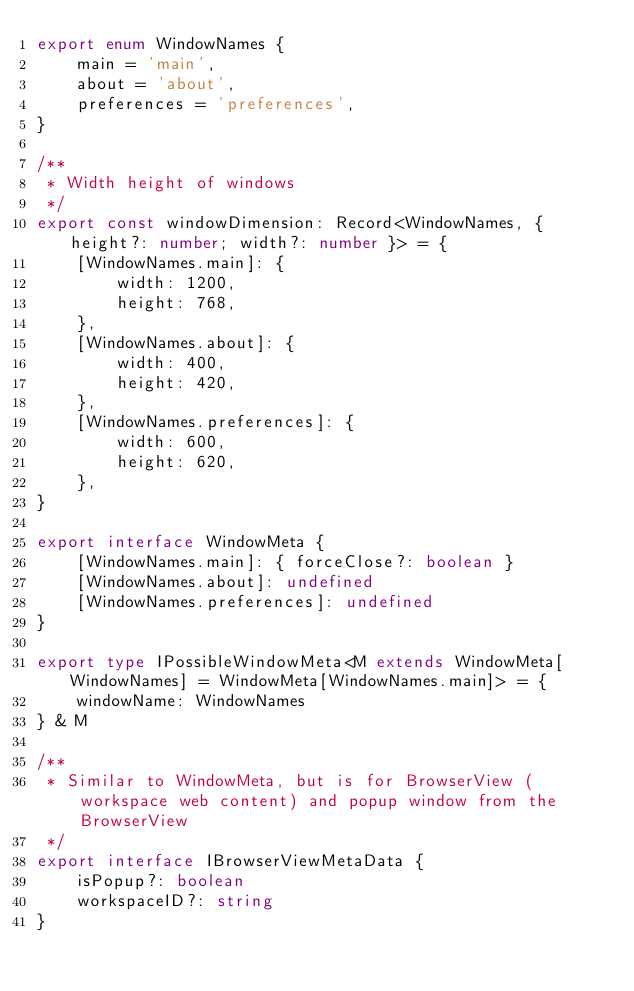Convert code to text. <code><loc_0><loc_0><loc_500><loc_500><_TypeScript_>export enum WindowNames {
    main = 'main',
    about = 'about',
    preferences = 'preferences',
}

/**
 * Width height of windows
 */
export const windowDimension: Record<WindowNames, { height?: number; width?: number }> = {
    [WindowNames.main]: {
        width: 1200,
        height: 768,
    },
    [WindowNames.about]: {
        width: 400,
        height: 420,
    },
    [WindowNames.preferences]: {
        width: 600,
        height: 620,
    },
}

export interface WindowMeta {
    [WindowNames.main]: { forceClose?: boolean }
    [WindowNames.about]: undefined
    [WindowNames.preferences]: undefined
}

export type IPossibleWindowMeta<M extends WindowMeta[WindowNames] = WindowMeta[WindowNames.main]> = {
    windowName: WindowNames
} & M

/**
 * Similar to WindowMeta, but is for BrowserView (workspace web content) and popup window from the BrowserView
 */
export interface IBrowserViewMetaData {
    isPopup?: boolean
    workspaceID?: string
}
</code> 